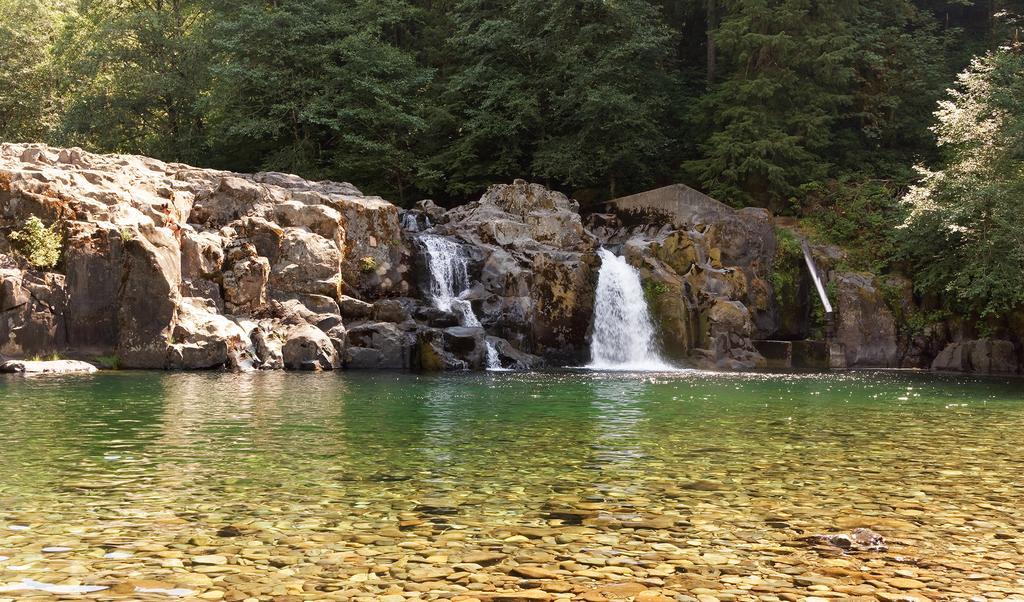In one or two sentences, can you explain what this image depicts? In this image there is a river, waterfall, rocks and trees. 